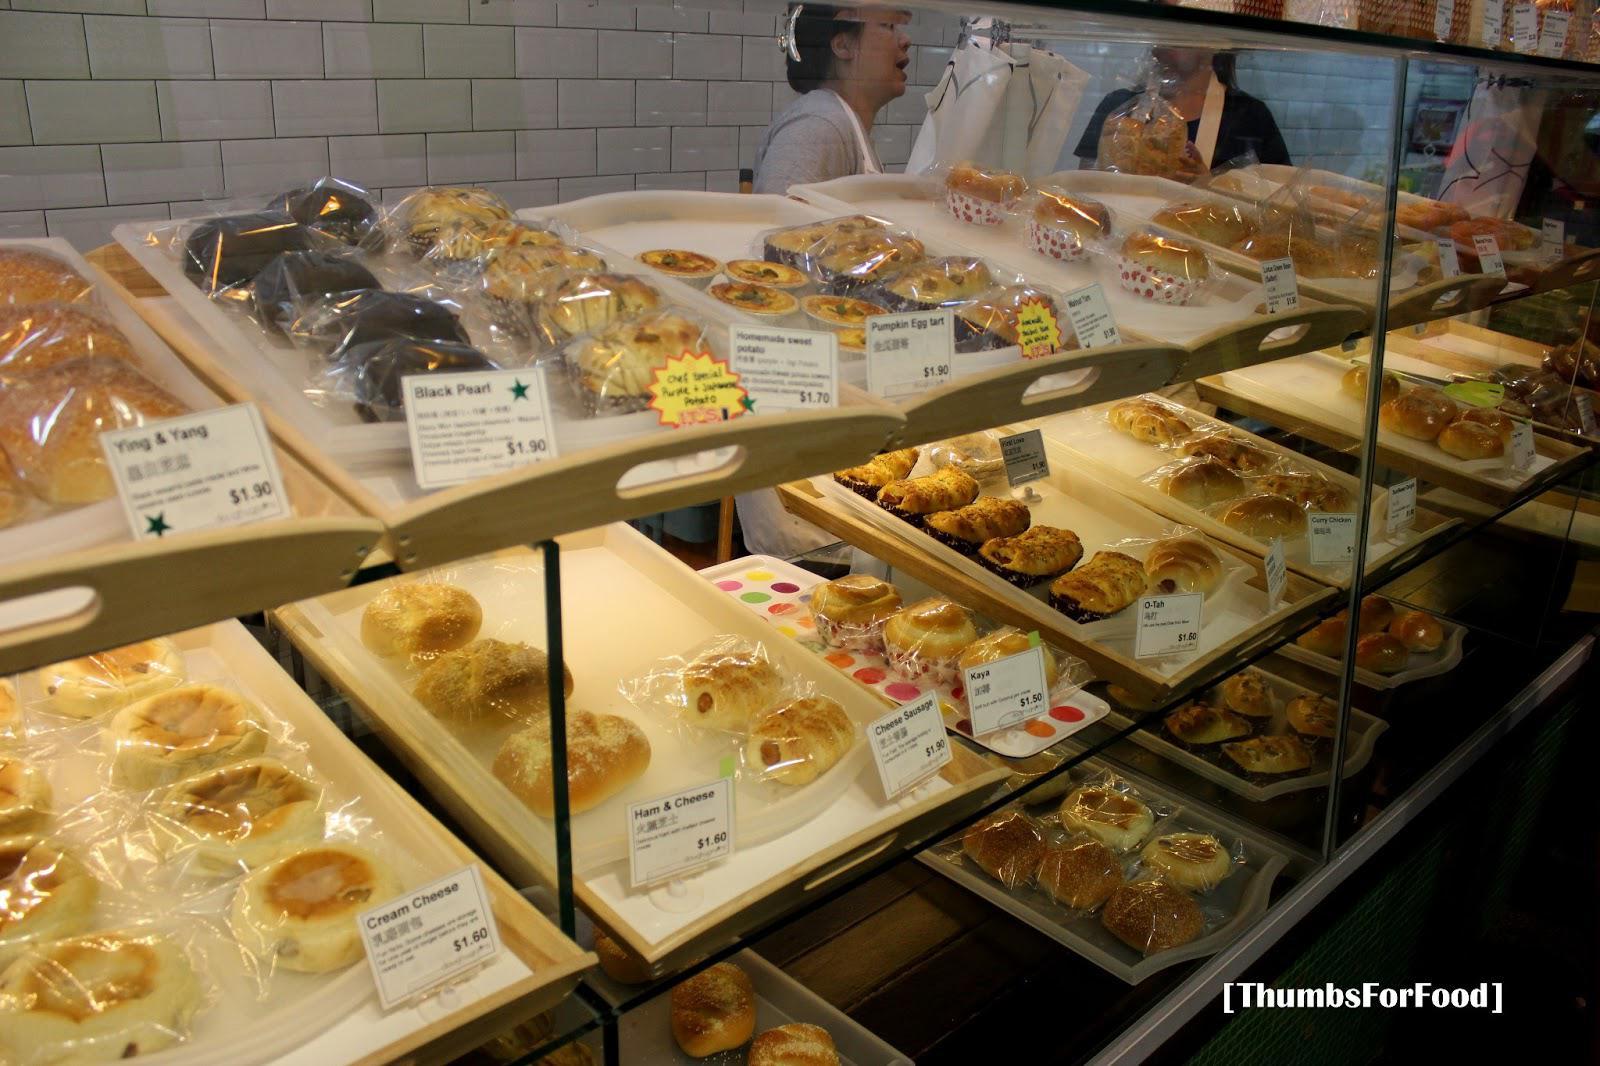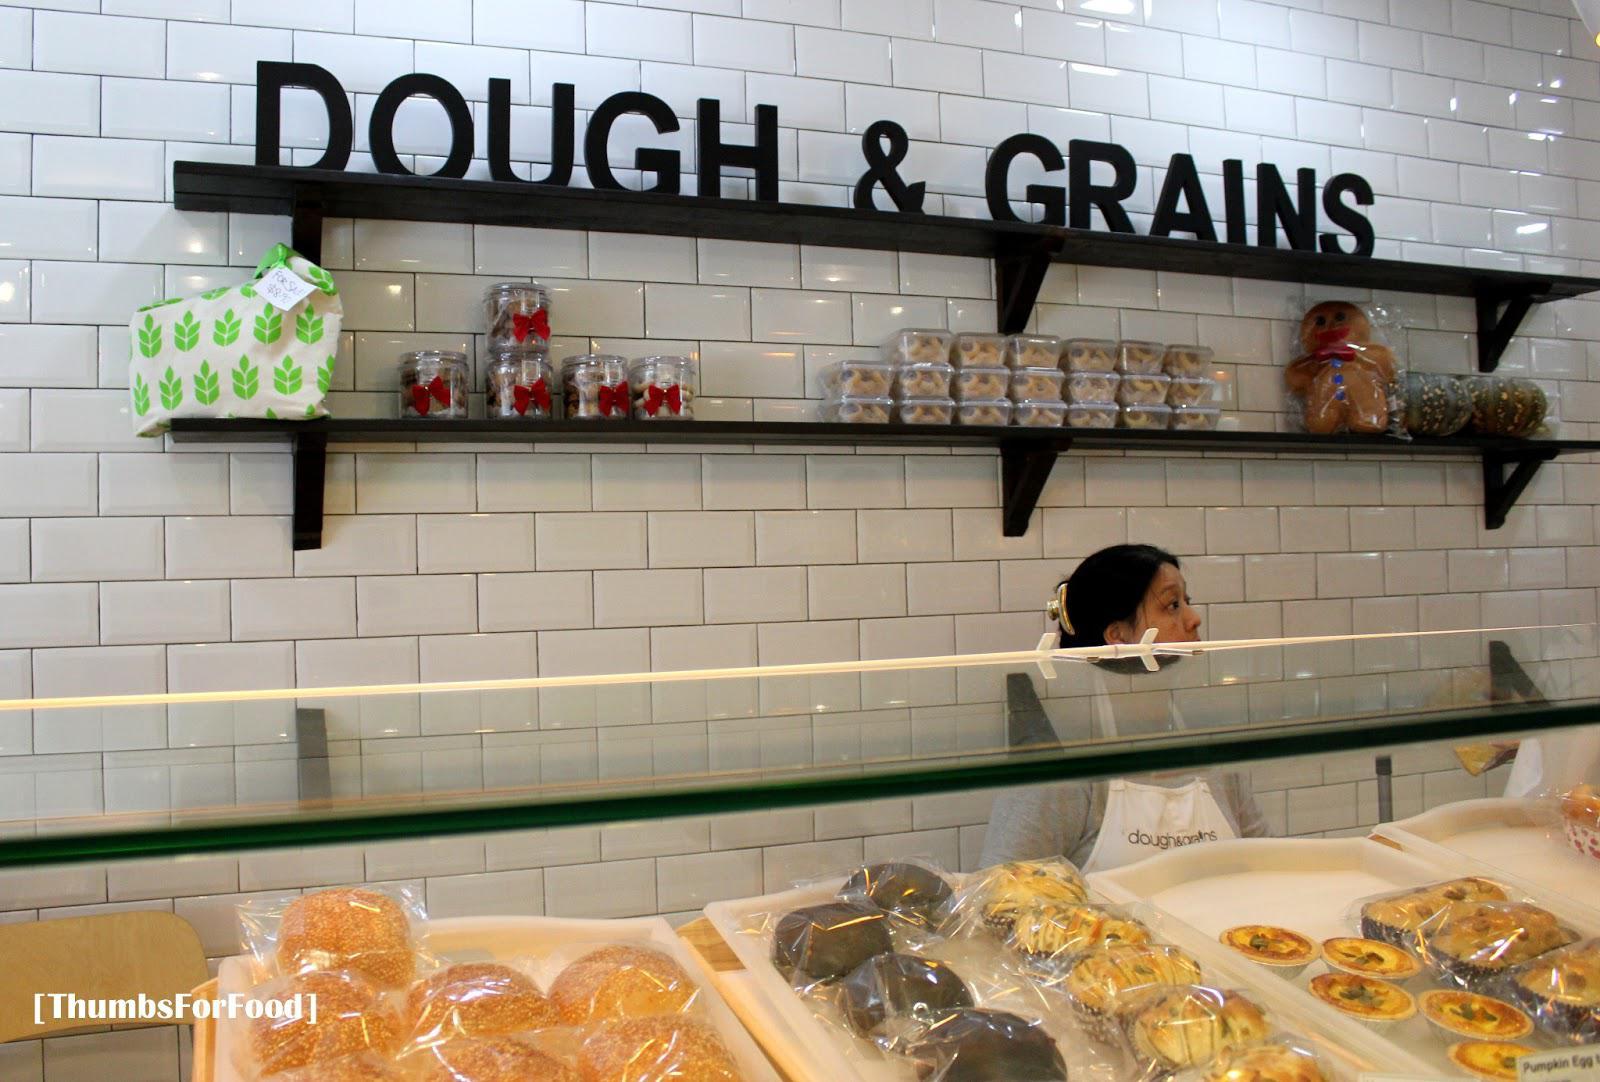The first image is the image on the left, the second image is the image on the right. For the images displayed, is the sentence "The left image features tiered shelves behind a glass case filled with side-by-side rectangular trays of baked goods, each with an oval cut-out tray handle facing the glass front." factually correct? Answer yes or no. Yes. The first image is the image on the left, the second image is the image on the right. Evaluate the accuracy of this statement regarding the images: "One of the shops advertises 'dough & grains'.". Is it true? Answer yes or no. Yes. 